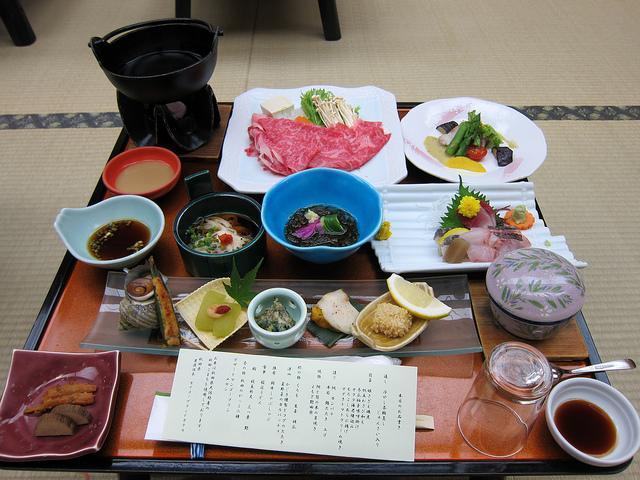How many cups can be seen?
Give a very brief answer. 2. How many bowls are in the picture?
Give a very brief answer. 9. How many rolls of white toilet paper are in the bathroom?
Give a very brief answer. 0. 